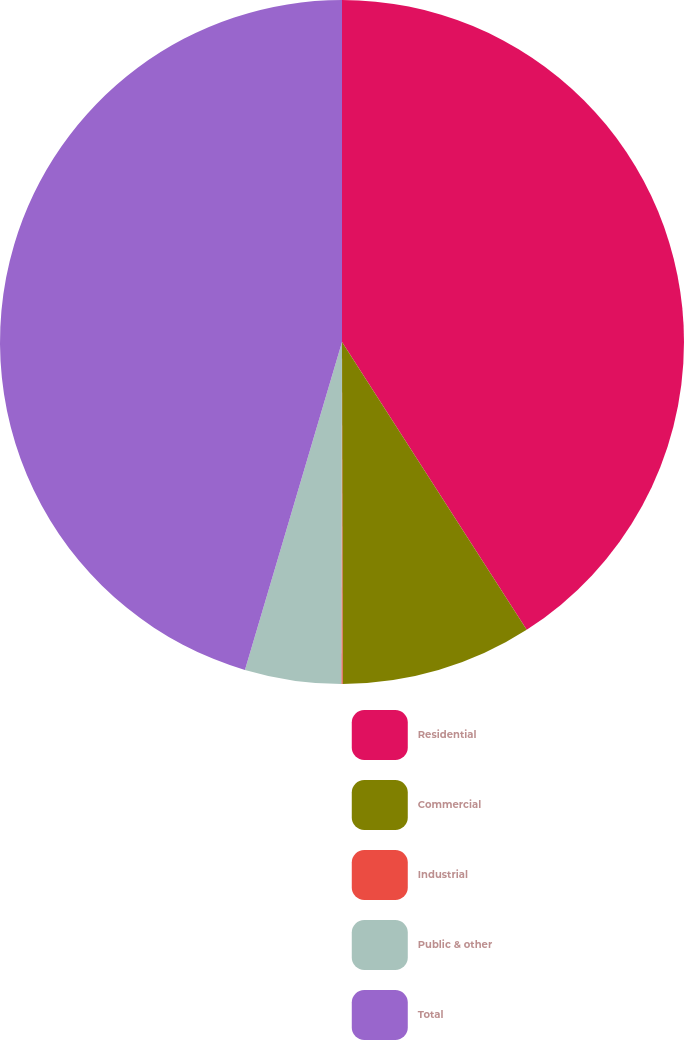Convert chart. <chart><loc_0><loc_0><loc_500><loc_500><pie_chart><fcel>Residential<fcel>Commercial<fcel>Industrial<fcel>Public & other<fcel>Total<nl><fcel>40.92%<fcel>9.05%<fcel>0.06%<fcel>4.55%<fcel>45.42%<nl></chart> 